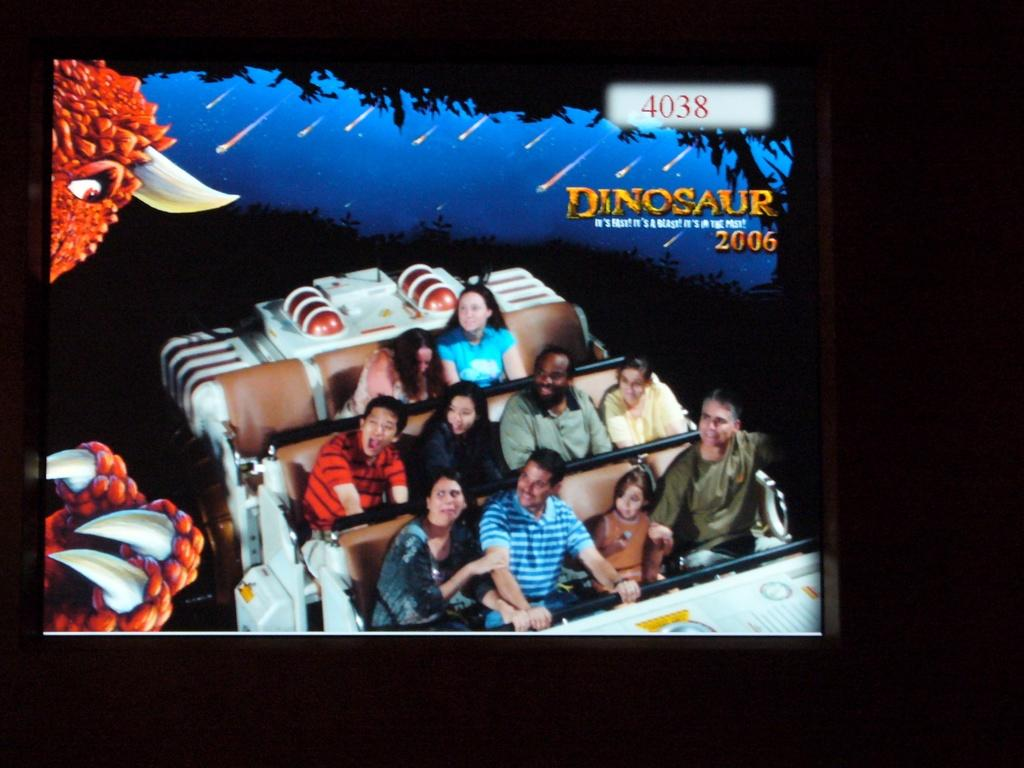Provide a one-sentence caption for the provided image. People are riding a roller coaster and it says Dinosaur above them. 